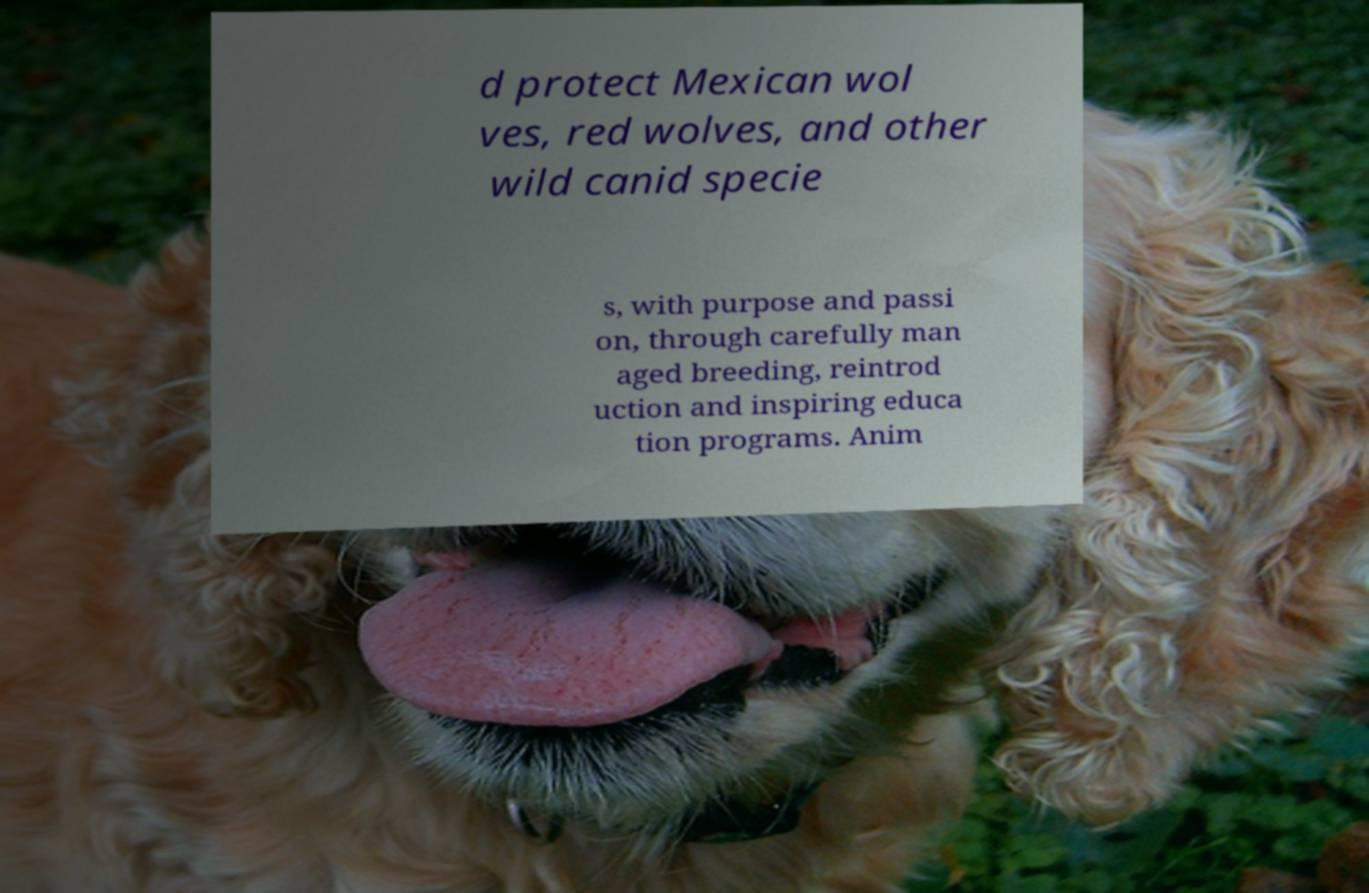Could you extract and type out the text from this image? d protect Mexican wol ves, red wolves, and other wild canid specie s, with purpose and passi on, through carefully man aged breeding, reintrod uction and inspiring educa tion programs. Anim 